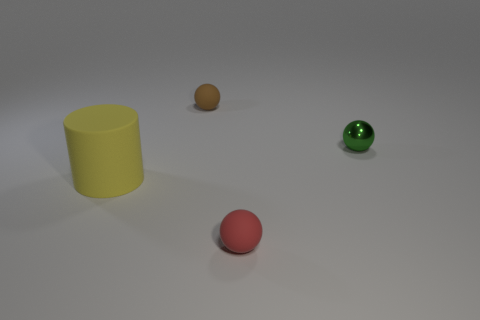There is a small matte object behind the small metal thing; is its shape the same as the matte thing that is right of the tiny brown sphere? yes 